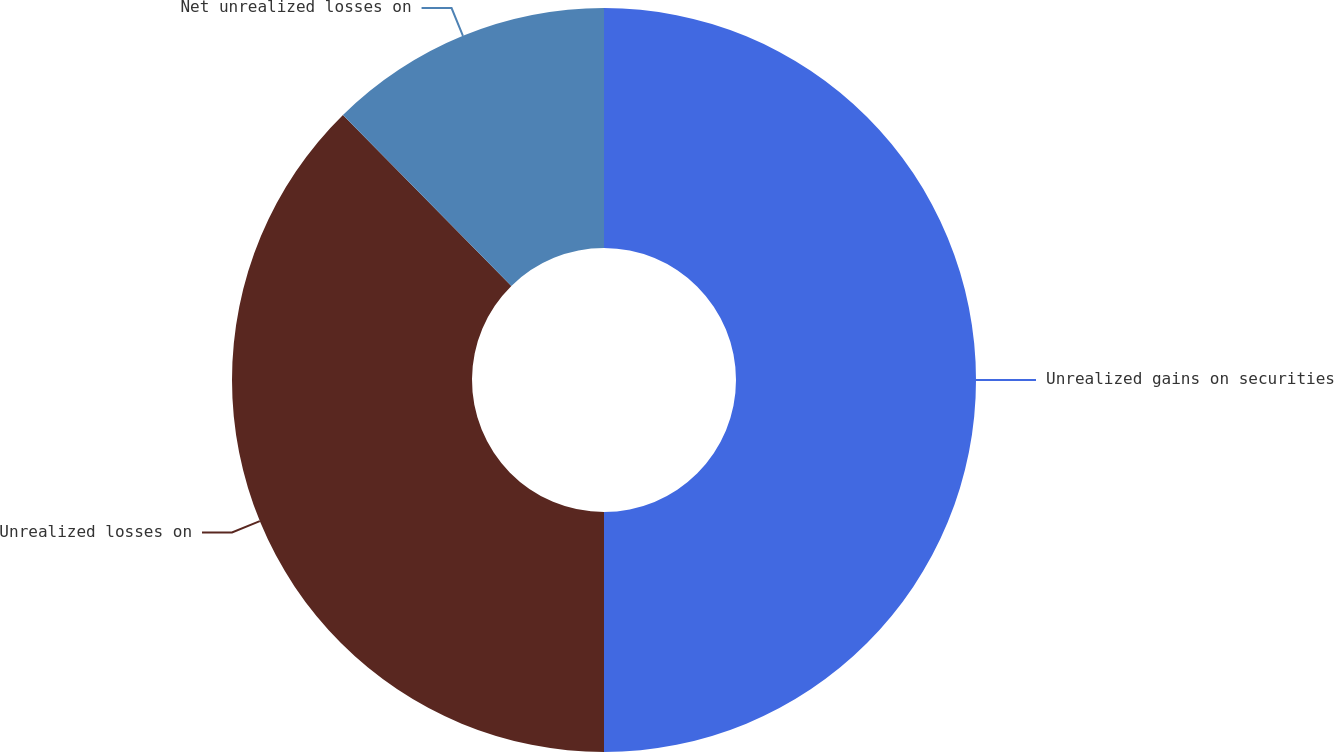Convert chart. <chart><loc_0><loc_0><loc_500><loc_500><pie_chart><fcel>Unrealized gains on securities<fcel>Unrealized losses on<fcel>Net unrealized losses on<nl><fcel>50.0%<fcel>37.62%<fcel>12.38%<nl></chart> 